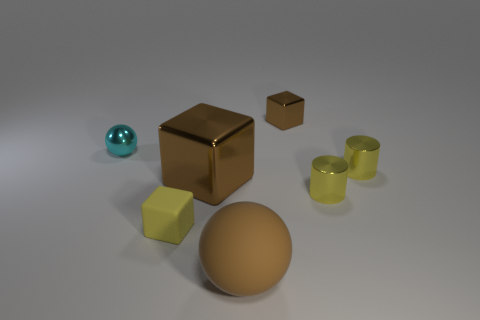There is a tiny cube that is in front of the block behind the shiny thing on the left side of the rubber cube; what color is it?
Your response must be concise. Yellow. There is a sphere that is to the right of the cyan ball; what is its color?
Give a very brief answer. Brown. There is another cube that is the same size as the yellow cube; what color is it?
Your answer should be very brief. Brown. Is the size of the matte ball the same as the cyan metallic sphere?
Provide a short and direct response. No. How many big brown shiny objects are in front of the cyan ball?
Your response must be concise. 1. How many things are either tiny objects that are behind the yellow rubber object or large purple metal things?
Offer a very short reply. 4. Is the number of small shiny cubes behind the yellow rubber cube greater than the number of large brown matte spheres that are behind the tiny brown object?
Offer a terse response. Yes. What is the size of the block that is the same color as the large shiny object?
Your answer should be very brief. Small. Is the size of the cyan ball the same as the brown metallic cube that is in front of the small brown metallic cube?
Ensure brevity in your answer.  No. How many cylinders are matte things or large brown metal objects?
Your response must be concise. 0. 